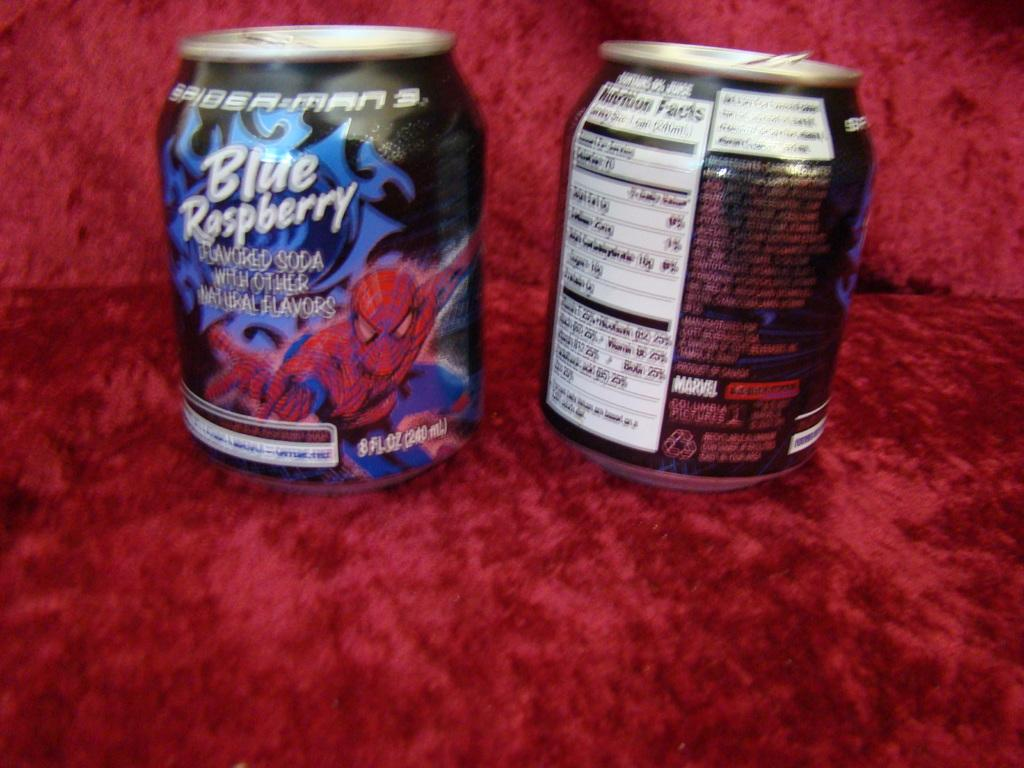<image>
Provide a brief description of the given image. Two small cans of Spider man 3 Blue Raspberry soda 